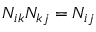Convert formula to latex. <formula><loc_0><loc_0><loc_500><loc_500>N _ { i k } N _ { k j } = N _ { i j }</formula> 